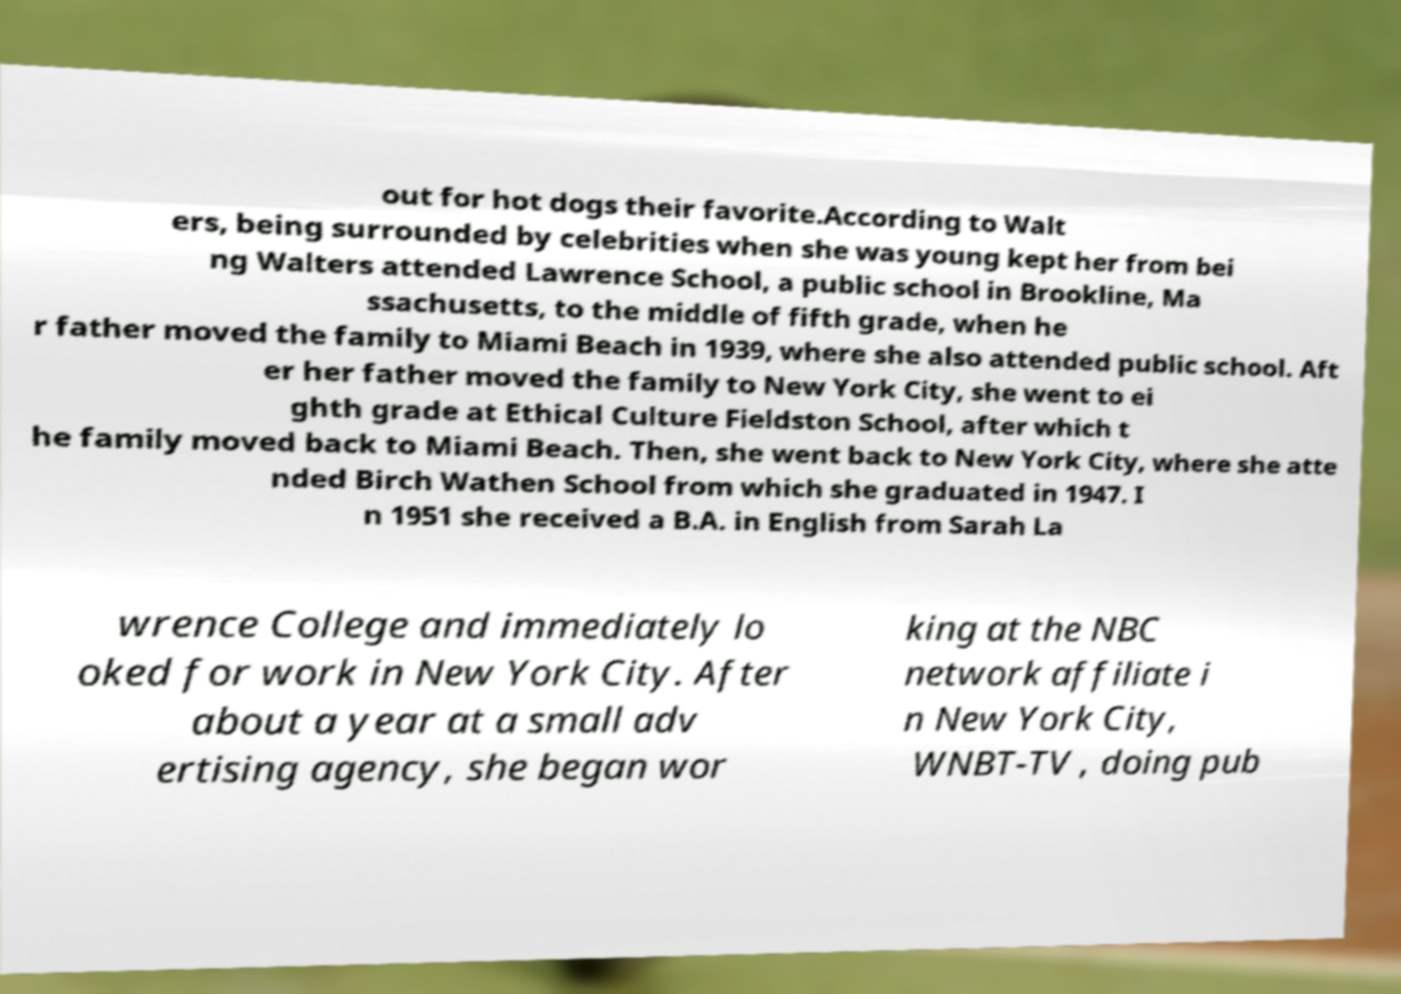Can you read and provide the text displayed in the image?This photo seems to have some interesting text. Can you extract and type it out for me? out for hot dogs their favorite.According to Walt ers, being surrounded by celebrities when she was young kept her from bei ng Walters attended Lawrence School, a public school in Brookline, Ma ssachusetts, to the middle of fifth grade, when he r father moved the family to Miami Beach in 1939, where she also attended public school. Aft er her father moved the family to New York City, she went to ei ghth grade at Ethical Culture Fieldston School, after which t he family moved back to Miami Beach. Then, she went back to New York City, where she atte nded Birch Wathen School from which she graduated in 1947. I n 1951 she received a B.A. in English from Sarah La wrence College and immediately lo oked for work in New York City. After about a year at a small adv ertising agency, she began wor king at the NBC network affiliate i n New York City, WNBT-TV , doing pub 